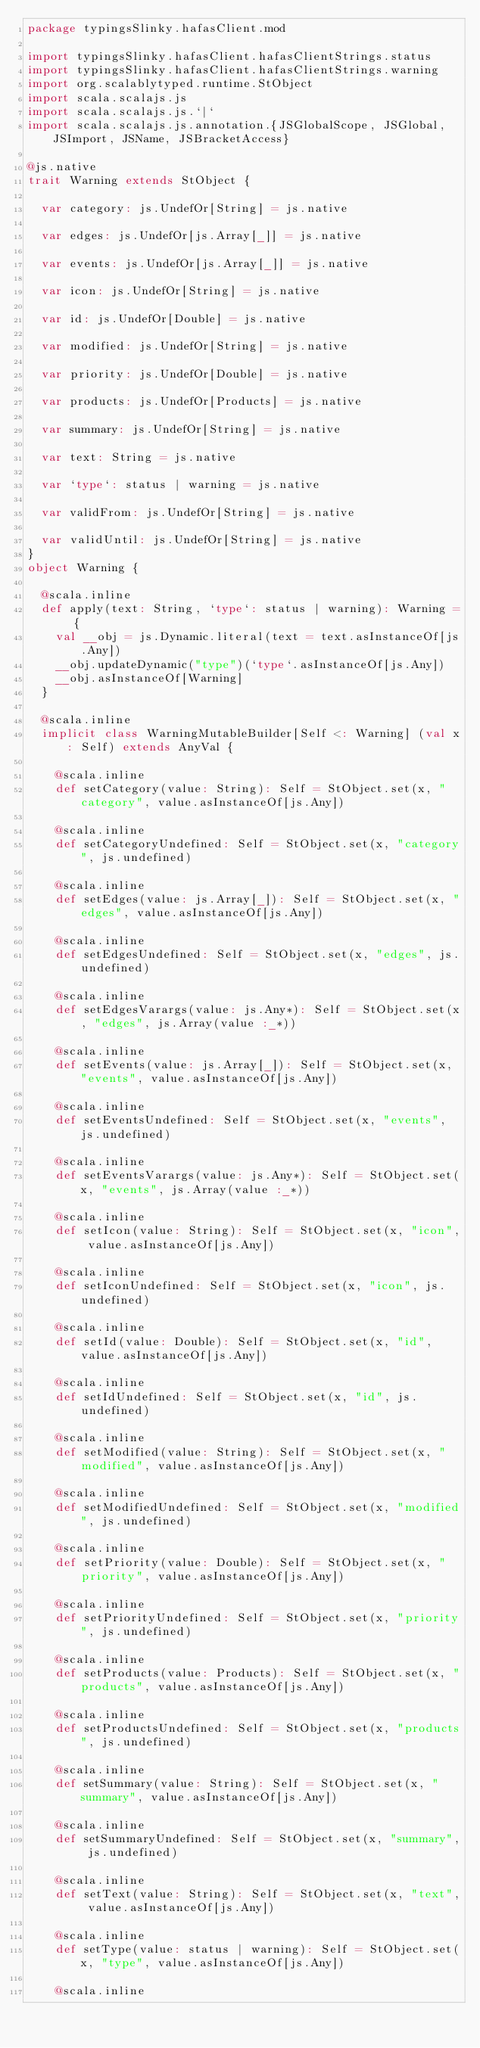Convert code to text. <code><loc_0><loc_0><loc_500><loc_500><_Scala_>package typingsSlinky.hafasClient.mod

import typingsSlinky.hafasClient.hafasClientStrings.status
import typingsSlinky.hafasClient.hafasClientStrings.warning
import org.scalablytyped.runtime.StObject
import scala.scalajs.js
import scala.scalajs.js.`|`
import scala.scalajs.js.annotation.{JSGlobalScope, JSGlobal, JSImport, JSName, JSBracketAccess}

@js.native
trait Warning extends StObject {
  
  var category: js.UndefOr[String] = js.native
  
  var edges: js.UndefOr[js.Array[_]] = js.native
  
  var events: js.UndefOr[js.Array[_]] = js.native
  
  var icon: js.UndefOr[String] = js.native
  
  var id: js.UndefOr[Double] = js.native
  
  var modified: js.UndefOr[String] = js.native
  
  var priority: js.UndefOr[Double] = js.native
  
  var products: js.UndefOr[Products] = js.native
  
  var summary: js.UndefOr[String] = js.native
  
  var text: String = js.native
  
  var `type`: status | warning = js.native
  
  var validFrom: js.UndefOr[String] = js.native
  
  var validUntil: js.UndefOr[String] = js.native
}
object Warning {
  
  @scala.inline
  def apply(text: String, `type`: status | warning): Warning = {
    val __obj = js.Dynamic.literal(text = text.asInstanceOf[js.Any])
    __obj.updateDynamic("type")(`type`.asInstanceOf[js.Any])
    __obj.asInstanceOf[Warning]
  }
  
  @scala.inline
  implicit class WarningMutableBuilder[Self <: Warning] (val x: Self) extends AnyVal {
    
    @scala.inline
    def setCategory(value: String): Self = StObject.set(x, "category", value.asInstanceOf[js.Any])
    
    @scala.inline
    def setCategoryUndefined: Self = StObject.set(x, "category", js.undefined)
    
    @scala.inline
    def setEdges(value: js.Array[_]): Self = StObject.set(x, "edges", value.asInstanceOf[js.Any])
    
    @scala.inline
    def setEdgesUndefined: Self = StObject.set(x, "edges", js.undefined)
    
    @scala.inline
    def setEdgesVarargs(value: js.Any*): Self = StObject.set(x, "edges", js.Array(value :_*))
    
    @scala.inline
    def setEvents(value: js.Array[_]): Self = StObject.set(x, "events", value.asInstanceOf[js.Any])
    
    @scala.inline
    def setEventsUndefined: Self = StObject.set(x, "events", js.undefined)
    
    @scala.inline
    def setEventsVarargs(value: js.Any*): Self = StObject.set(x, "events", js.Array(value :_*))
    
    @scala.inline
    def setIcon(value: String): Self = StObject.set(x, "icon", value.asInstanceOf[js.Any])
    
    @scala.inline
    def setIconUndefined: Self = StObject.set(x, "icon", js.undefined)
    
    @scala.inline
    def setId(value: Double): Self = StObject.set(x, "id", value.asInstanceOf[js.Any])
    
    @scala.inline
    def setIdUndefined: Self = StObject.set(x, "id", js.undefined)
    
    @scala.inline
    def setModified(value: String): Self = StObject.set(x, "modified", value.asInstanceOf[js.Any])
    
    @scala.inline
    def setModifiedUndefined: Self = StObject.set(x, "modified", js.undefined)
    
    @scala.inline
    def setPriority(value: Double): Self = StObject.set(x, "priority", value.asInstanceOf[js.Any])
    
    @scala.inline
    def setPriorityUndefined: Self = StObject.set(x, "priority", js.undefined)
    
    @scala.inline
    def setProducts(value: Products): Self = StObject.set(x, "products", value.asInstanceOf[js.Any])
    
    @scala.inline
    def setProductsUndefined: Self = StObject.set(x, "products", js.undefined)
    
    @scala.inline
    def setSummary(value: String): Self = StObject.set(x, "summary", value.asInstanceOf[js.Any])
    
    @scala.inline
    def setSummaryUndefined: Self = StObject.set(x, "summary", js.undefined)
    
    @scala.inline
    def setText(value: String): Self = StObject.set(x, "text", value.asInstanceOf[js.Any])
    
    @scala.inline
    def setType(value: status | warning): Self = StObject.set(x, "type", value.asInstanceOf[js.Any])
    
    @scala.inline</code> 